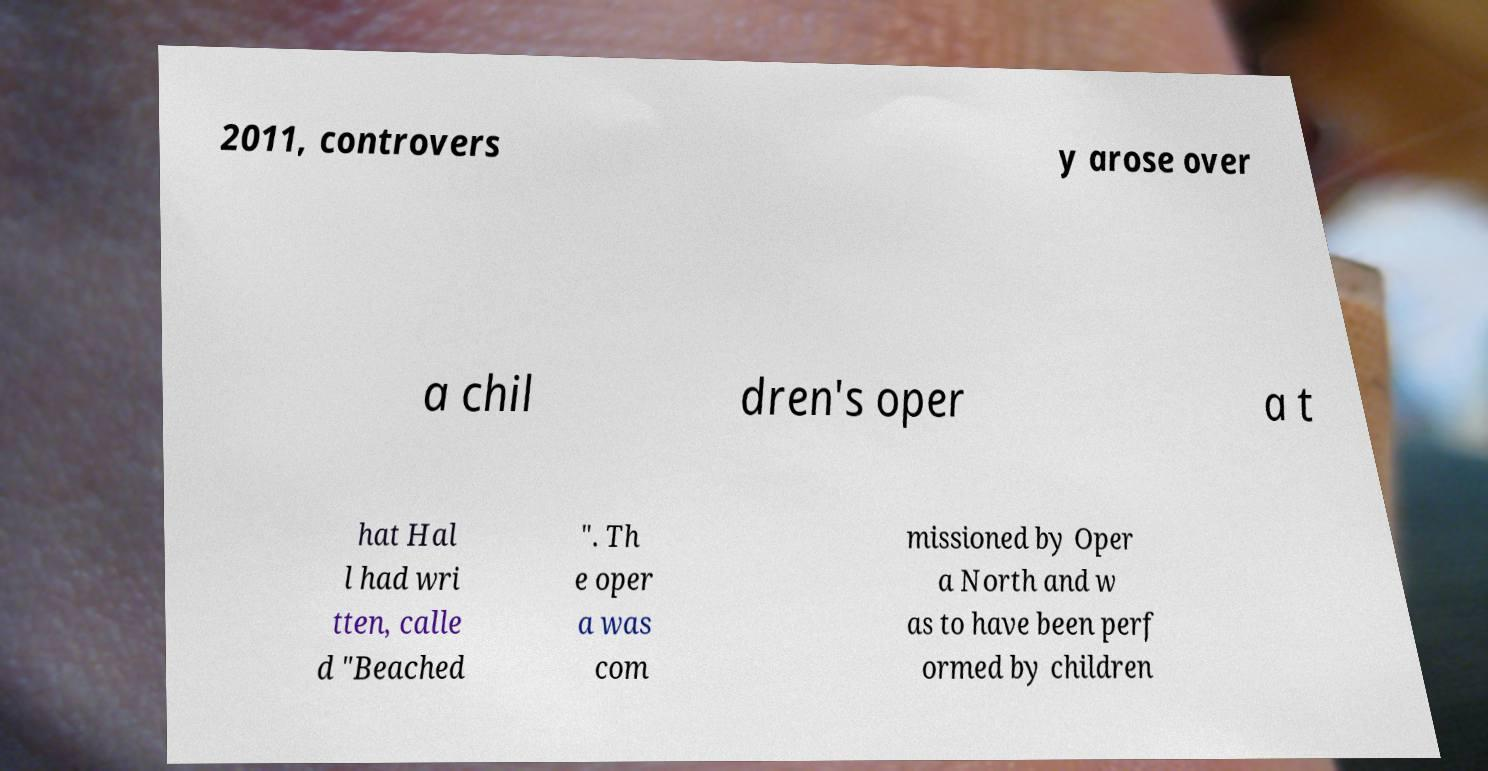Could you extract and type out the text from this image? 2011, controvers y arose over a chil dren's oper a t hat Hal l had wri tten, calle d "Beached ". Th e oper a was com missioned by Oper a North and w as to have been perf ormed by children 